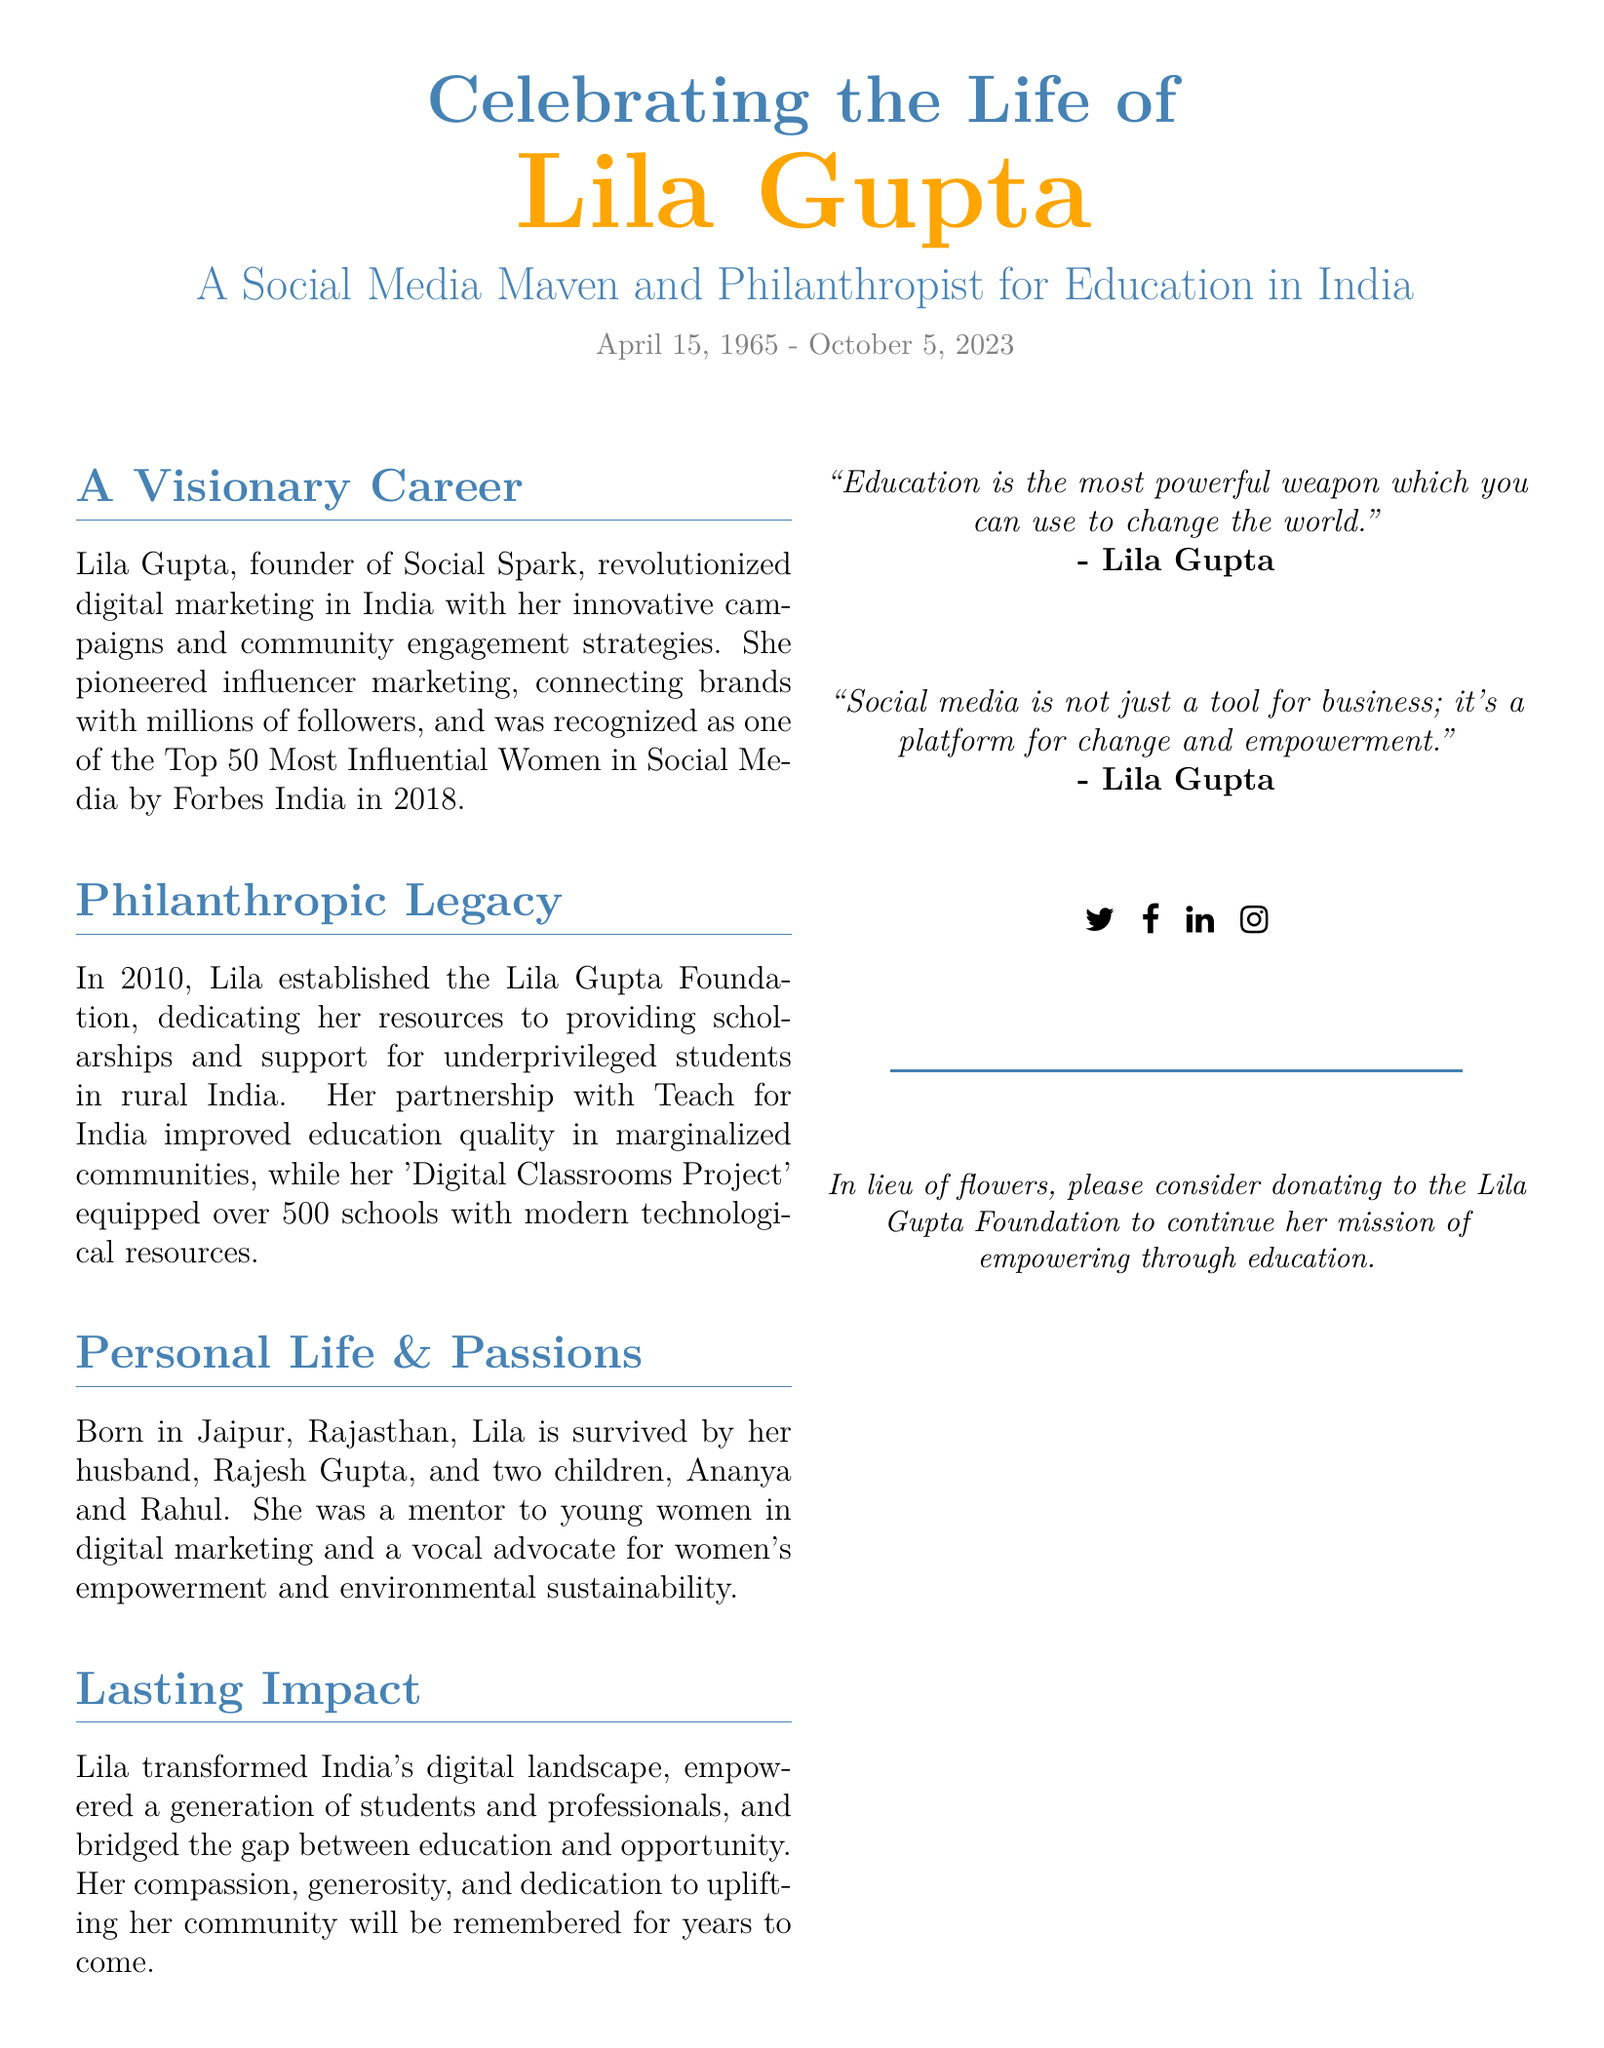What is the full name of the person celebrated in the obituary? The document provides a clear mention of the person's full name at the beginning.
Answer: Lila Gupta What organization did Lila Gupta found? The document states the name of the organization she founded under her professional achievements.
Answer: Social Spark When was the Lila Gupta Foundation established? The document specifies the year when the foundation was created as part of her philanthropic efforts.
Answer: 2010 What age was Lila Gupta at the time of her passing? The document provides her birth date and date of death; calculating the difference gives her age.
Answer: 58 How many schools were equipped with technological resources through the 'Digital Classrooms Project'? The document mentions the particular milestone of the project in assisting schools.
Answer: 500 Which city was Lila Gupta born in? The document includes her birthplace in the personal background section.
Answer: Jaipur What is one of the quotes attributed to Lila Gupta in the document? The document features a quote from Lila Gupta, showcasing her belief in education.
Answer: "Education is the most powerful weapon which you can use to change the world." What cause did Lila Gupta advocate for besides education? The document lists her advocacy efforts, revealing multiple interests.
Answer: Women's empowerment Who survives Lila Gupta? The document mentions family members who continue her legacy after her passing.
Answer: Rajesh Gupta, Ananya, Rahul 